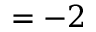<formula> <loc_0><loc_0><loc_500><loc_500>= - 2</formula> 